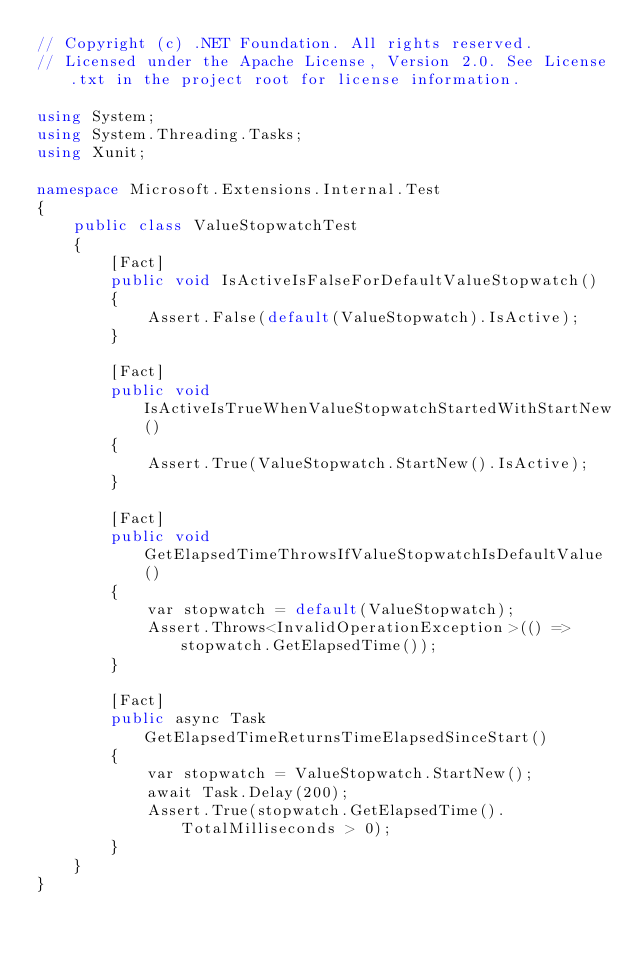<code> <loc_0><loc_0><loc_500><loc_500><_C#_>// Copyright (c) .NET Foundation. All rights reserved.
// Licensed under the Apache License, Version 2.0. See License.txt in the project root for license information.

using System;
using System.Threading.Tasks;
using Xunit;

namespace Microsoft.Extensions.Internal.Test
{
    public class ValueStopwatchTest
    {
        [Fact]
        public void IsActiveIsFalseForDefaultValueStopwatch()
        {
            Assert.False(default(ValueStopwatch).IsActive);
        }

        [Fact]
        public void IsActiveIsTrueWhenValueStopwatchStartedWithStartNew()
        {
            Assert.True(ValueStopwatch.StartNew().IsActive);
        }

        [Fact]
        public void GetElapsedTimeThrowsIfValueStopwatchIsDefaultValue()
        {
            var stopwatch = default(ValueStopwatch);
            Assert.Throws<InvalidOperationException>(() => stopwatch.GetElapsedTime());
        }

        [Fact]
        public async Task GetElapsedTimeReturnsTimeElapsedSinceStart()
        {
            var stopwatch = ValueStopwatch.StartNew();
            await Task.Delay(200);
            Assert.True(stopwatch.GetElapsedTime().TotalMilliseconds > 0);
        }
    }
}
</code> 